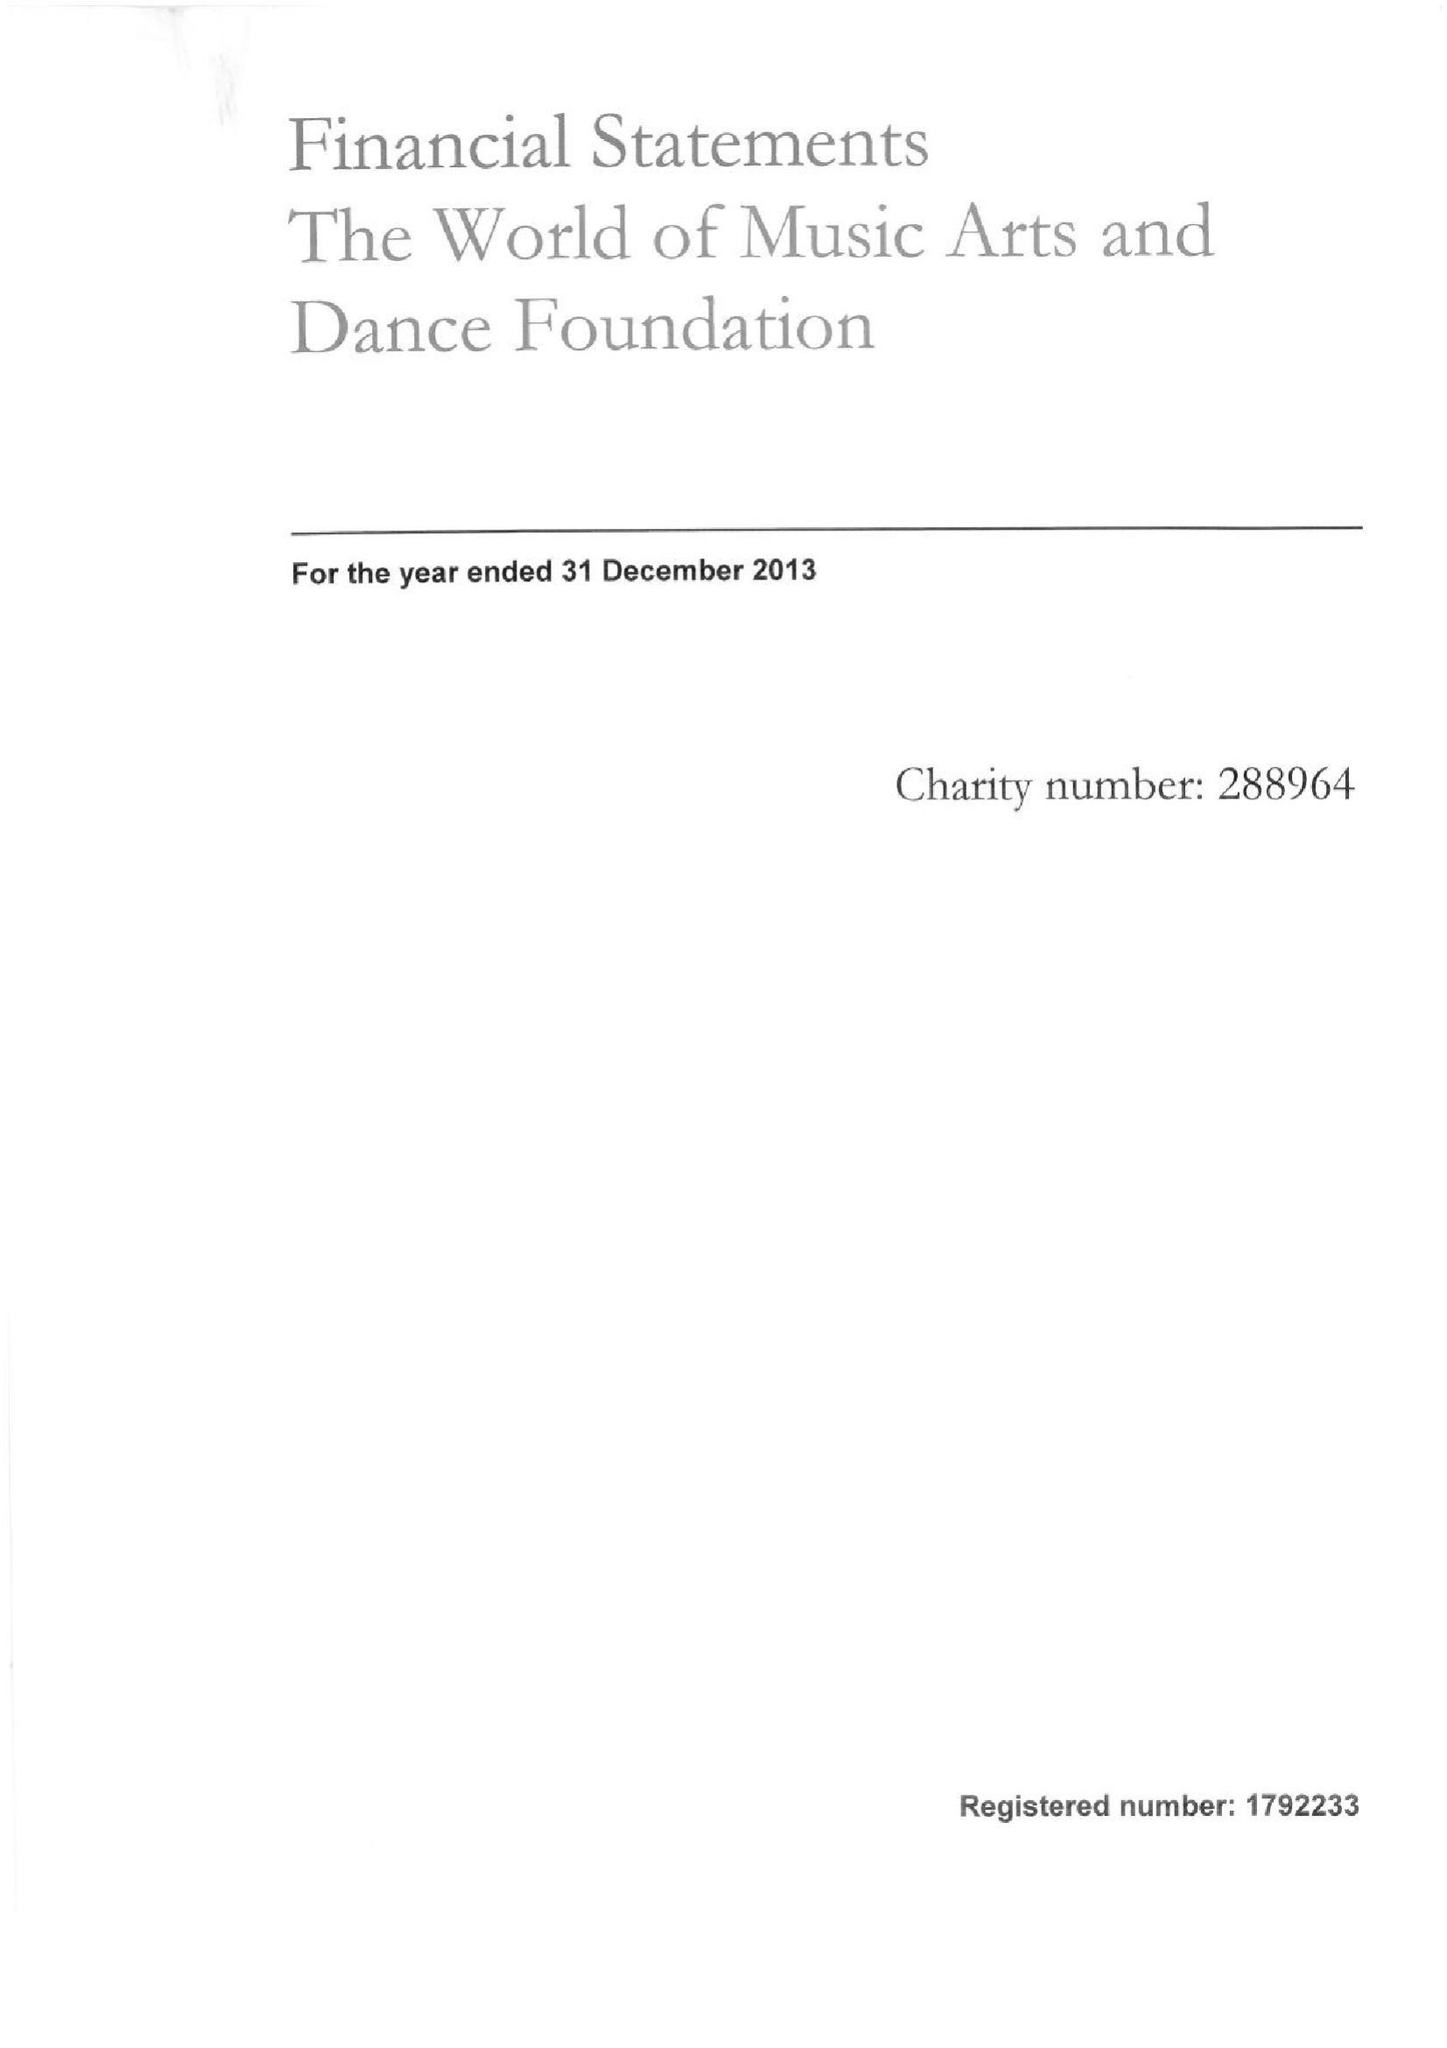What is the value for the address__postcode?
Answer the question using a single word or phrase. SN13 8PN 